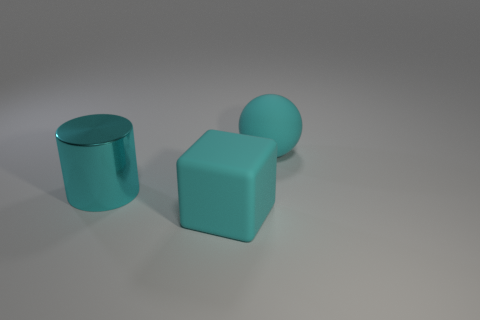Add 1 large blocks. How many objects exist? 4 Subtract all blocks. How many objects are left? 2 Add 3 blocks. How many blocks are left? 4 Add 3 large cyan rubber spheres. How many large cyan rubber spheres exist? 4 Subtract 0 blue cylinders. How many objects are left? 3 Subtract all green rubber cubes. Subtract all rubber spheres. How many objects are left? 2 